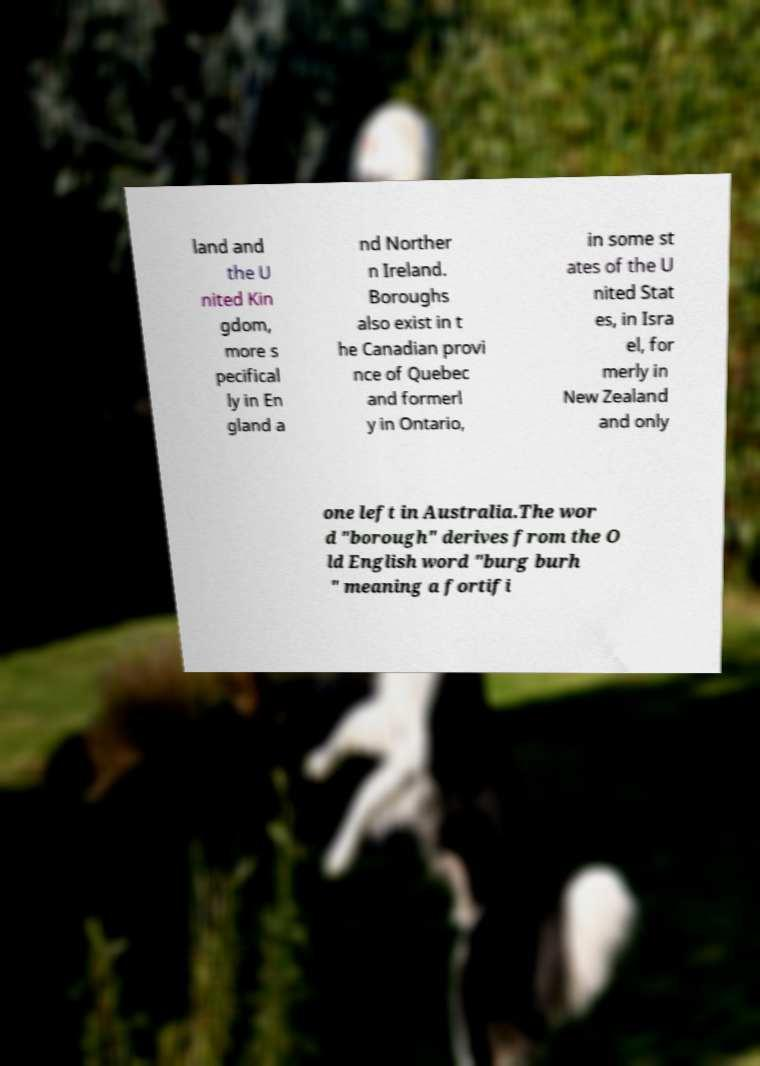For documentation purposes, I need the text within this image transcribed. Could you provide that? land and the U nited Kin gdom, more s pecifical ly in En gland a nd Norther n Ireland. Boroughs also exist in t he Canadian provi nce of Quebec and formerl y in Ontario, in some st ates of the U nited Stat es, in Isra el, for merly in New Zealand and only one left in Australia.The wor d "borough" derives from the O ld English word "burg burh " meaning a fortifi 